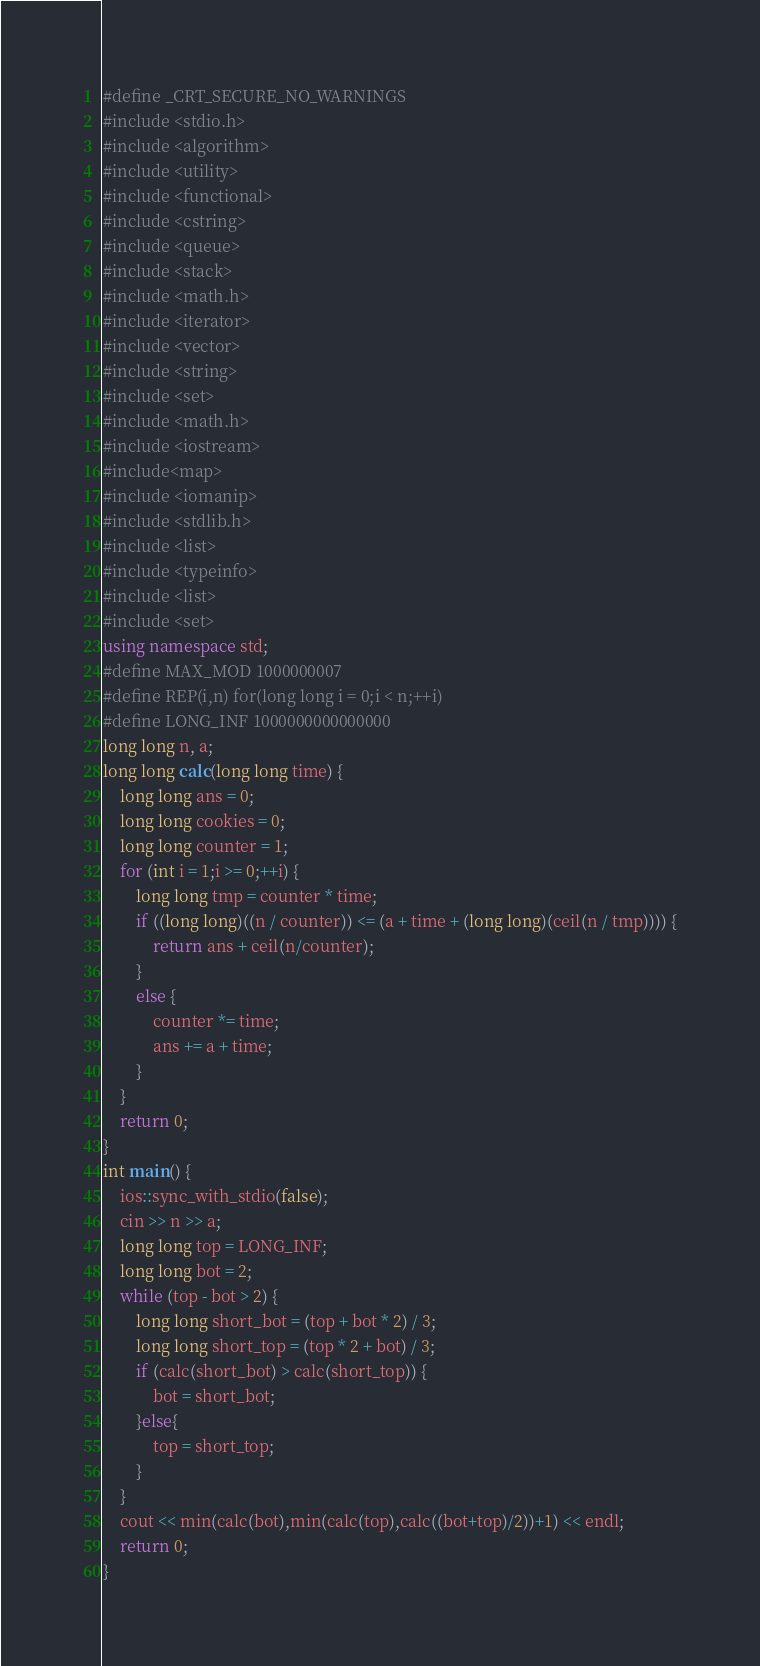Convert code to text. <code><loc_0><loc_0><loc_500><loc_500><_C++_>#define _CRT_SECURE_NO_WARNINGS
#include <stdio.h>
#include <algorithm>
#include <utility>
#include <functional>
#include <cstring>
#include <queue>
#include <stack>
#include <math.h>
#include <iterator>
#include <vector>
#include <string>
#include <set>
#include <math.h>
#include <iostream> 
#include<map>
#include <iomanip>
#include <stdlib.h>
#include <list>
#include <typeinfo>
#include <list>
#include <set>
using namespace std;
#define MAX_MOD 1000000007
#define REP(i,n) for(long long i = 0;i < n;++i)
#define LONG_INF 1000000000000000
long long n, a;
long long calc(long long time) {
	long long ans = 0;
	long long cookies = 0;
	long long counter = 1;
	for (int i = 1;i >= 0;++i) {
		long long tmp = counter * time;
		if ((long long)((n / counter)) <= (a + time + (long long)(ceil(n / tmp)))) {
			return ans + ceil(n/counter);
		}
		else {
			counter *= time;
			ans += a + time;
		}
	}
	return 0;
}
int main() {
	ios::sync_with_stdio(false);
	cin >> n >> a;
	long long top = LONG_INF;
	long long bot = 2;
	while (top - bot > 2) {
		long long short_bot = (top + bot * 2) / 3;
		long long short_top = (top * 2 + bot) / 3;
		if (calc(short_bot) > calc(short_top)) {
			bot = short_bot;
		}else{
			top = short_top;
		}
	}
	cout << min(calc(bot),min(calc(top),calc((bot+top)/2))+1) << endl;
	return 0;
}
</code> 